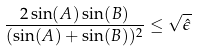Convert formula to latex. <formula><loc_0><loc_0><loc_500><loc_500>\frac { 2 \sin ( A ) \sin ( B ) } { ( \sin ( A ) + \sin ( B ) ) ^ { 2 } } \leq \sqrt { \hat { \epsilon } }</formula> 